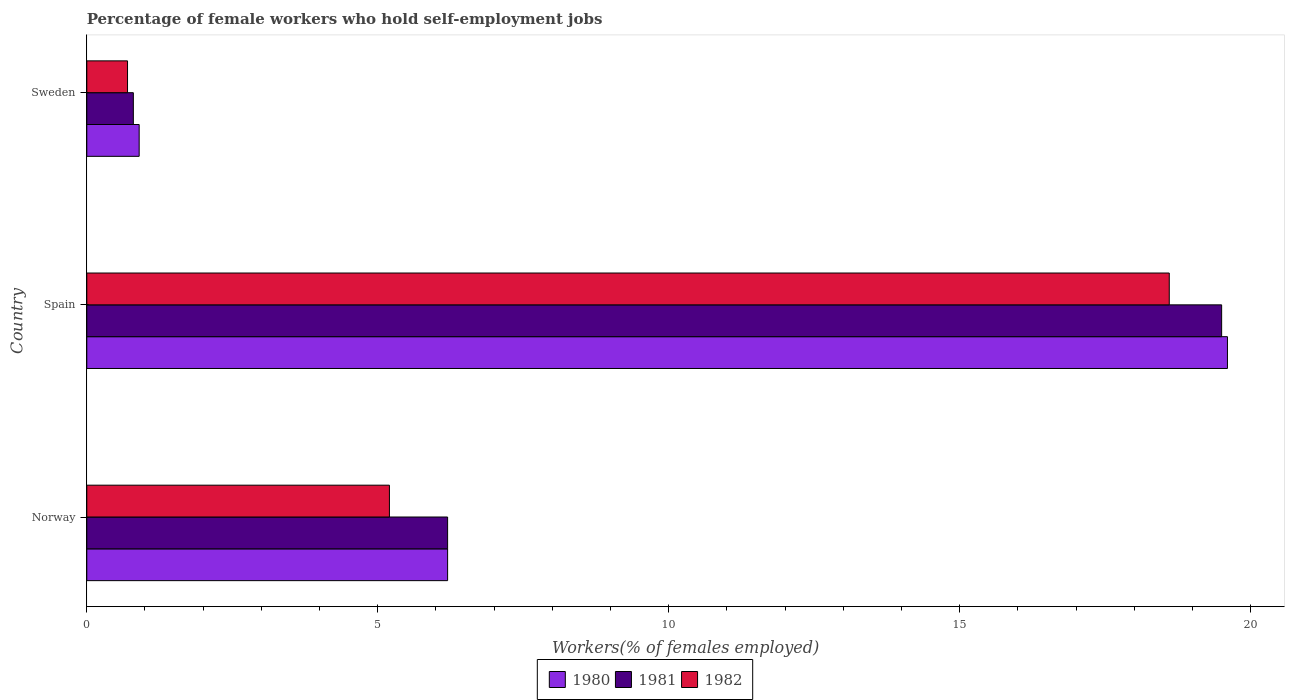How many bars are there on the 2nd tick from the bottom?
Your answer should be compact. 3. What is the label of the 1st group of bars from the top?
Make the answer very short. Sweden. What is the percentage of self-employed female workers in 1982 in Spain?
Your answer should be compact. 18.6. Across all countries, what is the maximum percentage of self-employed female workers in 1980?
Offer a very short reply. 19.6. Across all countries, what is the minimum percentage of self-employed female workers in 1980?
Ensure brevity in your answer.  0.9. In which country was the percentage of self-employed female workers in 1982 maximum?
Ensure brevity in your answer.  Spain. In which country was the percentage of self-employed female workers in 1980 minimum?
Keep it short and to the point. Sweden. What is the total percentage of self-employed female workers in 1982 in the graph?
Give a very brief answer. 24.5. What is the difference between the percentage of self-employed female workers in 1980 in Spain and that in Sweden?
Your answer should be very brief. 18.7. What is the difference between the percentage of self-employed female workers in 1982 in Spain and the percentage of self-employed female workers in 1980 in Sweden?
Your answer should be very brief. 17.7. What is the average percentage of self-employed female workers in 1982 per country?
Make the answer very short. 8.17. What is the difference between the percentage of self-employed female workers in 1980 and percentage of self-employed female workers in 1982 in Norway?
Offer a very short reply. 1. In how many countries, is the percentage of self-employed female workers in 1981 greater than 10 %?
Give a very brief answer. 1. What is the ratio of the percentage of self-employed female workers in 1982 in Norway to that in Sweden?
Give a very brief answer. 7.43. What is the difference between the highest and the second highest percentage of self-employed female workers in 1981?
Provide a short and direct response. 13.3. What is the difference between the highest and the lowest percentage of self-employed female workers in 1980?
Keep it short and to the point. 18.7. Is the sum of the percentage of self-employed female workers in 1980 in Spain and Sweden greater than the maximum percentage of self-employed female workers in 1982 across all countries?
Make the answer very short. Yes. What does the 1st bar from the top in Spain represents?
Your answer should be compact. 1982. Are all the bars in the graph horizontal?
Offer a very short reply. Yes. What is the difference between two consecutive major ticks on the X-axis?
Offer a terse response. 5. Are the values on the major ticks of X-axis written in scientific E-notation?
Give a very brief answer. No. Does the graph contain any zero values?
Your answer should be very brief. No. Does the graph contain grids?
Your answer should be very brief. No. Where does the legend appear in the graph?
Provide a succinct answer. Bottom center. How many legend labels are there?
Provide a succinct answer. 3. How are the legend labels stacked?
Your response must be concise. Horizontal. What is the title of the graph?
Provide a succinct answer. Percentage of female workers who hold self-employment jobs. Does "2012" appear as one of the legend labels in the graph?
Ensure brevity in your answer.  No. What is the label or title of the X-axis?
Your response must be concise. Workers(% of females employed). What is the label or title of the Y-axis?
Give a very brief answer. Country. What is the Workers(% of females employed) in 1980 in Norway?
Ensure brevity in your answer.  6.2. What is the Workers(% of females employed) in 1981 in Norway?
Make the answer very short. 6.2. What is the Workers(% of females employed) of 1982 in Norway?
Provide a succinct answer. 5.2. What is the Workers(% of females employed) in 1980 in Spain?
Offer a very short reply. 19.6. What is the Workers(% of females employed) of 1982 in Spain?
Provide a short and direct response. 18.6. What is the Workers(% of females employed) in 1980 in Sweden?
Keep it short and to the point. 0.9. What is the Workers(% of females employed) of 1981 in Sweden?
Ensure brevity in your answer.  0.8. What is the Workers(% of females employed) in 1982 in Sweden?
Provide a short and direct response. 0.7. Across all countries, what is the maximum Workers(% of females employed) in 1980?
Your response must be concise. 19.6. Across all countries, what is the maximum Workers(% of females employed) of 1982?
Ensure brevity in your answer.  18.6. Across all countries, what is the minimum Workers(% of females employed) of 1980?
Your answer should be very brief. 0.9. Across all countries, what is the minimum Workers(% of females employed) of 1981?
Keep it short and to the point. 0.8. Across all countries, what is the minimum Workers(% of females employed) of 1982?
Your answer should be very brief. 0.7. What is the total Workers(% of females employed) in 1980 in the graph?
Your response must be concise. 26.7. What is the total Workers(% of females employed) of 1982 in the graph?
Your answer should be compact. 24.5. What is the difference between the Workers(% of females employed) of 1982 in Norway and that in Spain?
Keep it short and to the point. -13.4. What is the difference between the Workers(% of females employed) in 1981 in Norway and that in Sweden?
Offer a very short reply. 5.4. What is the difference between the Workers(% of females employed) of 1982 in Norway and that in Sweden?
Offer a very short reply. 4.5. What is the difference between the Workers(% of females employed) of 1980 in Spain and that in Sweden?
Ensure brevity in your answer.  18.7. What is the difference between the Workers(% of females employed) in 1981 in Spain and that in Sweden?
Keep it short and to the point. 18.7. What is the difference between the Workers(% of females employed) in 1982 in Spain and that in Sweden?
Your response must be concise. 17.9. What is the difference between the Workers(% of females employed) in 1980 in Norway and the Workers(% of females employed) in 1981 in Spain?
Ensure brevity in your answer.  -13.3. What is the difference between the Workers(% of females employed) in 1980 in Norway and the Workers(% of females employed) in 1982 in Spain?
Keep it short and to the point. -12.4. What is the difference between the Workers(% of females employed) of 1981 in Norway and the Workers(% of females employed) of 1982 in Spain?
Provide a short and direct response. -12.4. What is the difference between the Workers(% of females employed) of 1980 in Norway and the Workers(% of females employed) of 1981 in Sweden?
Your response must be concise. 5.4. What is the difference between the Workers(% of females employed) in 1980 in Norway and the Workers(% of females employed) in 1982 in Sweden?
Offer a very short reply. 5.5. What is the difference between the Workers(% of females employed) in 1980 in Spain and the Workers(% of females employed) in 1981 in Sweden?
Make the answer very short. 18.8. What is the difference between the Workers(% of females employed) of 1980 in Spain and the Workers(% of females employed) of 1982 in Sweden?
Keep it short and to the point. 18.9. What is the difference between the Workers(% of females employed) in 1981 in Spain and the Workers(% of females employed) in 1982 in Sweden?
Ensure brevity in your answer.  18.8. What is the average Workers(% of females employed) in 1980 per country?
Offer a terse response. 8.9. What is the average Workers(% of females employed) of 1981 per country?
Provide a succinct answer. 8.83. What is the average Workers(% of females employed) in 1982 per country?
Give a very brief answer. 8.17. What is the difference between the Workers(% of females employed) of 1980 and Workers(% of females employed) of 1981 in Norway?
Provide a succinct answer. 0. What is the difference between the Workers(% of females employed) of 1980 and Workers(% of females employed) of 1982 in Norway?
Offer a terse response. 1. What is the difference between the Workers(% of females employed) of 1981 and Workers(% of females employed) of 1982 in Norway?
Give a very brief answer. 1. What is the difference between the Workers(% of females employed) in 1980 and Workers(% of females employed) in 1982 in Spain?
Keep it short and to the point. 1. What is the difference between the Workers(% of females employed) in 1981 and Workers(% of females employed) in 1982 in Spain?
Provide a succinct answer. 0.9. What is the difference between the Workers(% of females employed) in 1980 and Workers(% of females employed) in 1981 in Sweden?
Offer a terse response. 0.1. What is the difference between the Workers(% of females employed) of 1980 and Workers(% of females employed) of 1982 in Sweden?
Offer a terse response. 0.2. What is the ratio of the Workers(% of females employed) in 1980 in Norway to that in Spain?
Offer a terse response. 0.32. What is the ratio of the Workers(% of females employed) of 1981 in Norway to that in Spain?
Your answer should be compact. 0.32. What is the ratio of the Workers(% of females employed) of 1982 in Norway to that in Spain?
Make the answer very short. 0.28. What is the ratio of the Workers(% of females employed) of 1980 in Norway to that in Sweden?
Offer a terse response. 6.89. What is the ratio of the Workers(% of females employed) in 1981 in Norway to that in Sweden?
Keep it short and to the point. 7.75. What is the ratio of the Workers(% of females employed) in 1982 in Norway to that in Sweden?
Ensure brevity in your answer.  7.43. What is the ratio of the Workers(% of females employed) in 1980 in Spain to that in Sweden?
Offer a very short reply. 21.78. What is the ratio of the Workers(% of females employed) in 1981 in Spain to that in Sweden?
Offer a terse response. 24.38. What is the ratio of the Workers(% of females employed) in 1982 in Spain to that in Sweden?
Ensure brevity in your answer.  26.57. What is the difference between the highest and the second highest Workers(% of females employed) of 1980?
Offer a terse response. 13.4. What is the difference between the highest and the second highest Workers(% of females employed) in 1981?
Provide a short and direct response. 13.3. What is the difference between the highest and the lowest Workers(% of females employed) in 1980?
Your answer should be very brief. 18.7. 